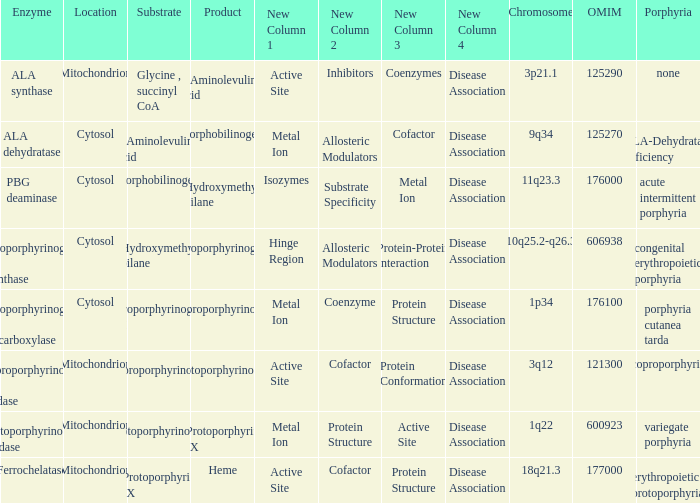What is the location of the enzyme Uroporphyrinogen iii Synthase? Cytosol. 